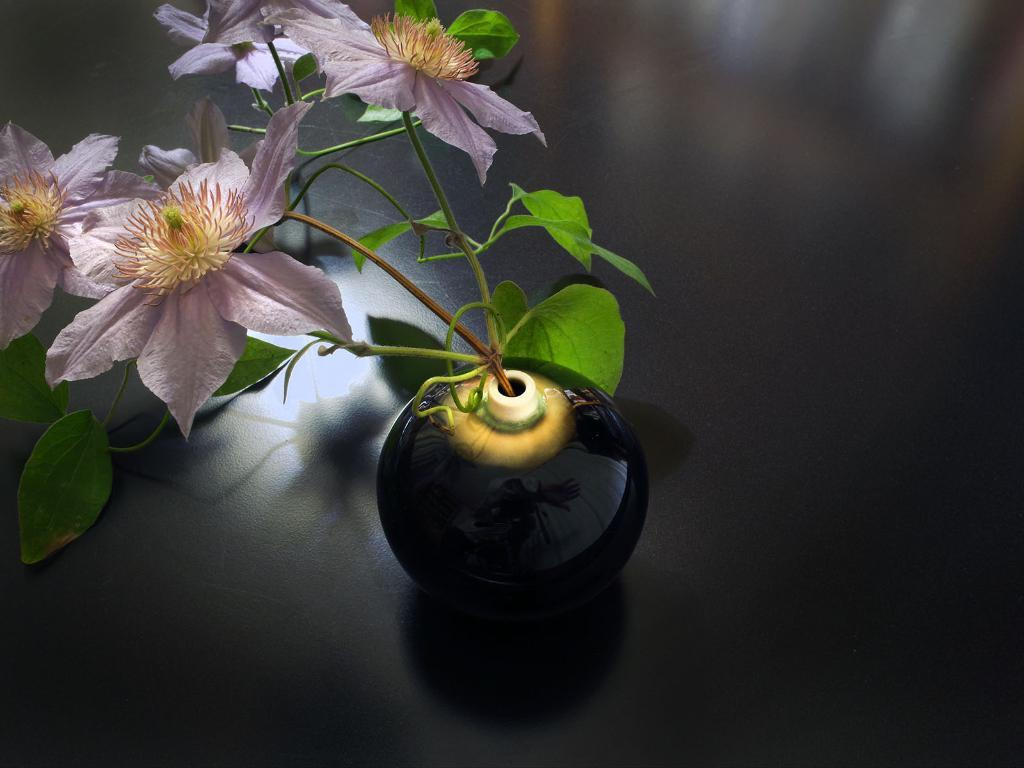What object is present in the image that is typically used for holding plants? There is a flower pot in the image. On what surface is the flower pot placed? The flower pot is placed on a black color surface. What type of cactus can be seen growing inside the flower pot in the image? There is no cactus visible inside the flower pot in the image. What emotion is being expressed by the flower pot in the image? The flower pot is an inanimate object and does not express emotions like hate. 